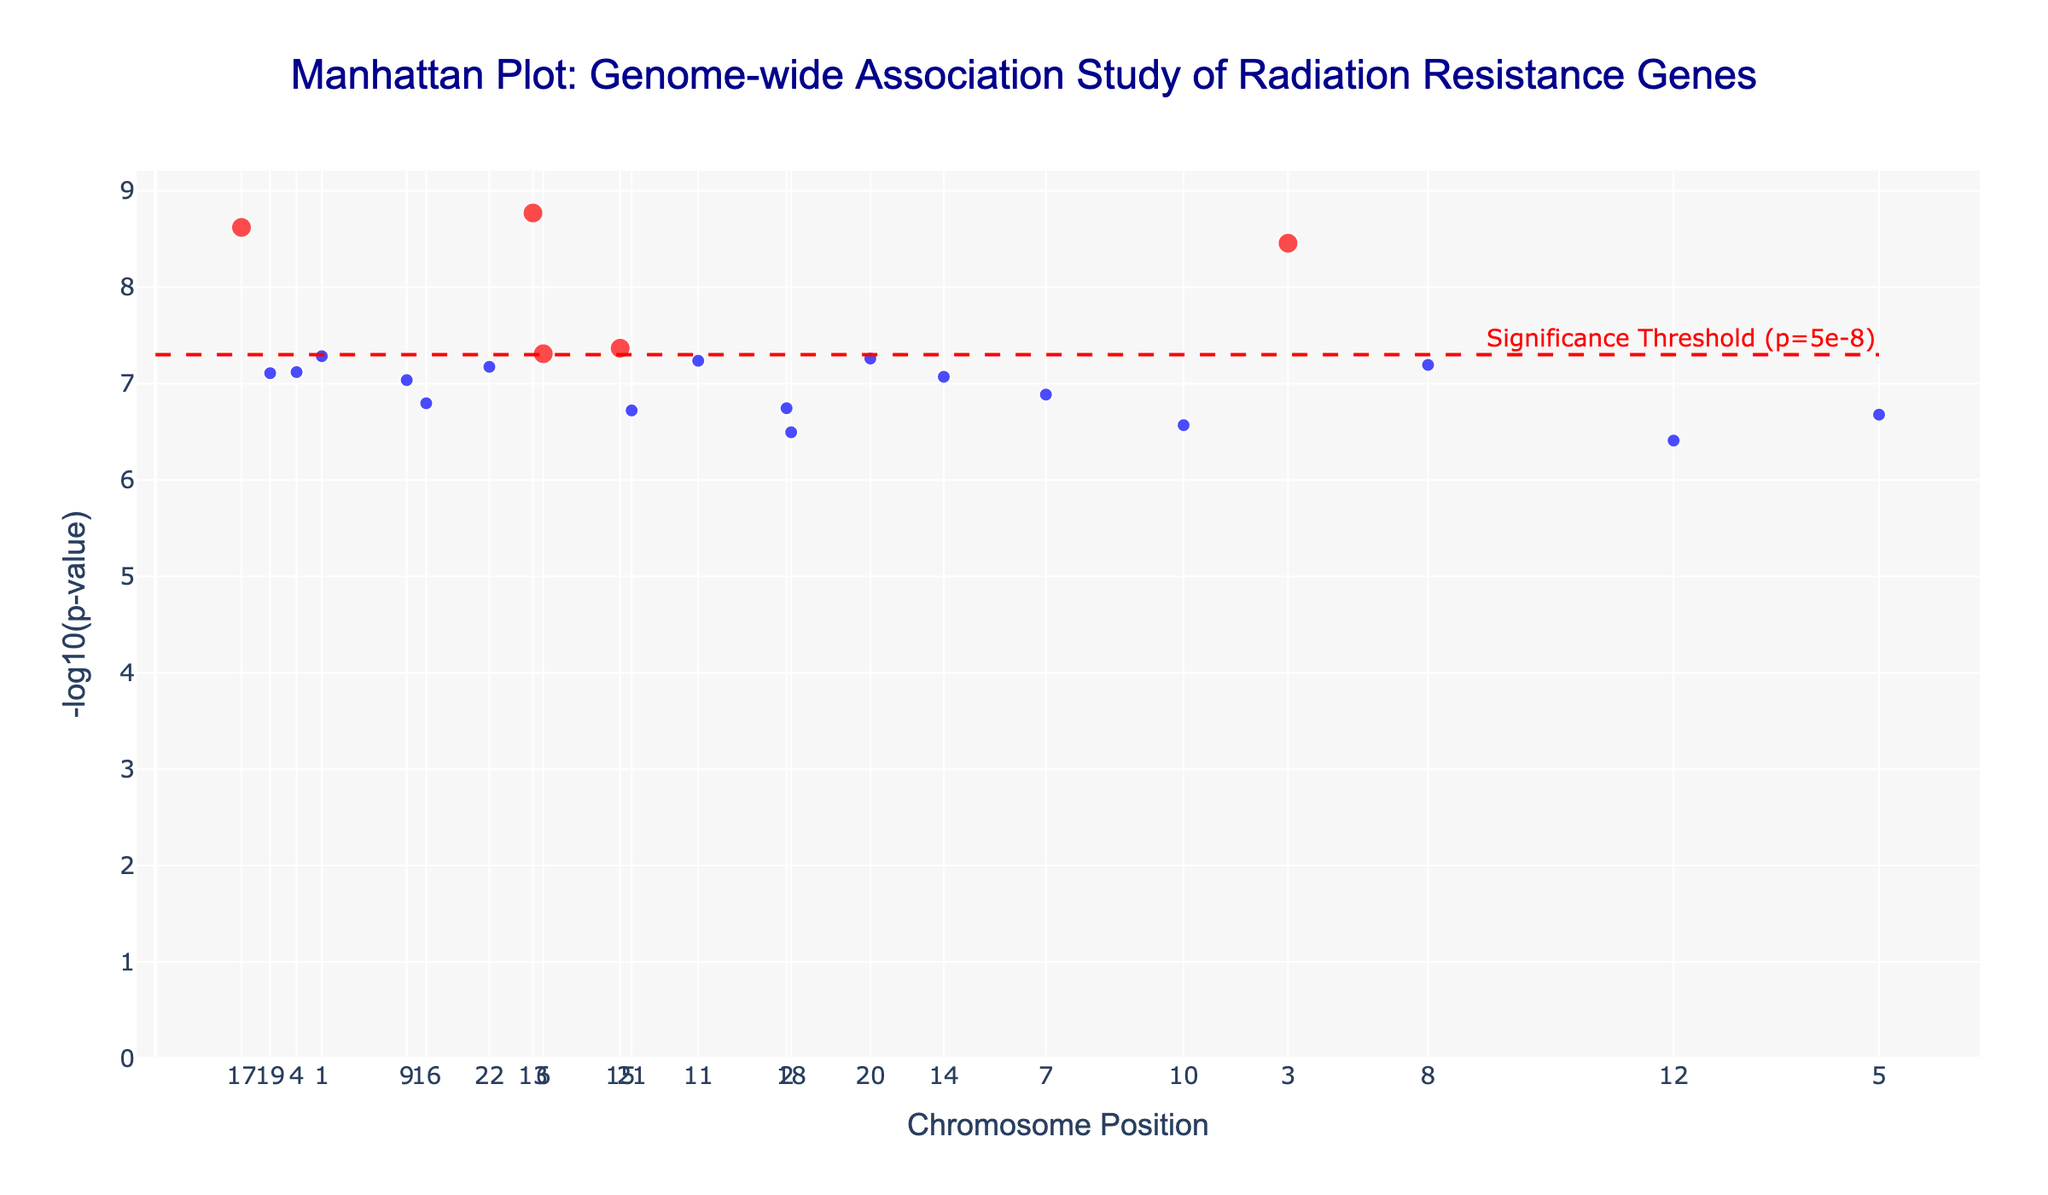What is the title of the figure? The title is displayed prominently at the top of the figure. It reads "Manhattan Plot: Genome-wide Association Study of Radiation Resistance Genes".
Answer: Manhattan Plot: Genome-wide Association Study of Radiation Resistance Genes What is represented on the x-axis and y-axis? The x-axis represents Chromosome Positions, and the y-axis represents -log10(p-value). These are labeled accordingly in the plot.
Answer: Chromosome Positions and -log10(p-value) Which gene has the smallest p-value? The smallest p-value will correspond to the highest point on the y-axis since the y-axis represents -log10(p-value). The gene at the highest point is "ATM" on chromosome 3.
Answer: ATM How many data points fall below the significance threshold of p=5e-8? Data points below the significance threshold are highlighted in red in the plot. Counting the red points gives the answer.
Answer: 7 Which chromosomes have genes with p-values below the significance threshold? Chromosomes with red points have genes with p-values below the significance threshold of p=5e-8. These chromosomes are 1, 3, 4, 6, 9, 13, and 17.
Answer: 1, 3, 4, 6, 9, 13, 17 Among the genes with significant p-values, which gene is located at the highest chromosome position? To find this, check the chromosome positions of the red points. For each chromosome, identify the highest position gene. The gene on chromosome 6 (FANCD2, position 33800000) has the highest position among significant genes.
Answer: FANCD2 What is the significance threshold shown in the plot? The significance threshold line is labeled on the plot as "Significance Threshold (p=5e-8)" and is represented by a red dashed line.
Answer: p=5e-8 Compare the -log10(p-value) of RAD51 and TP53 genes. Which one has a higher value? To compare, locate the points for RAD51 (chromosome 1) and TP53 (chromosome 17) on the y-axis. The point for TP53 is higher on the y-axis than RAD51.
Answer: TP53 What is the average -log10(p-value) of genes RAD51 and BRCA2? Locate the points for RAD51 (chromosome 1) and BRCA2 (chromosome 4), check their y-values (-log10(p-value)), then take the average. RAD51: 7.28, BRCA2: 7.12. (7.28 + 7.12) / 2 = 7.2
Answer: 7.2 Which gene has the highest -log10(p-value) on chromosome 2? Check the y-axis values of genes on chromosome 2. XRCC5 is the only gene on chromosome 2.
Answer: XRCC5 